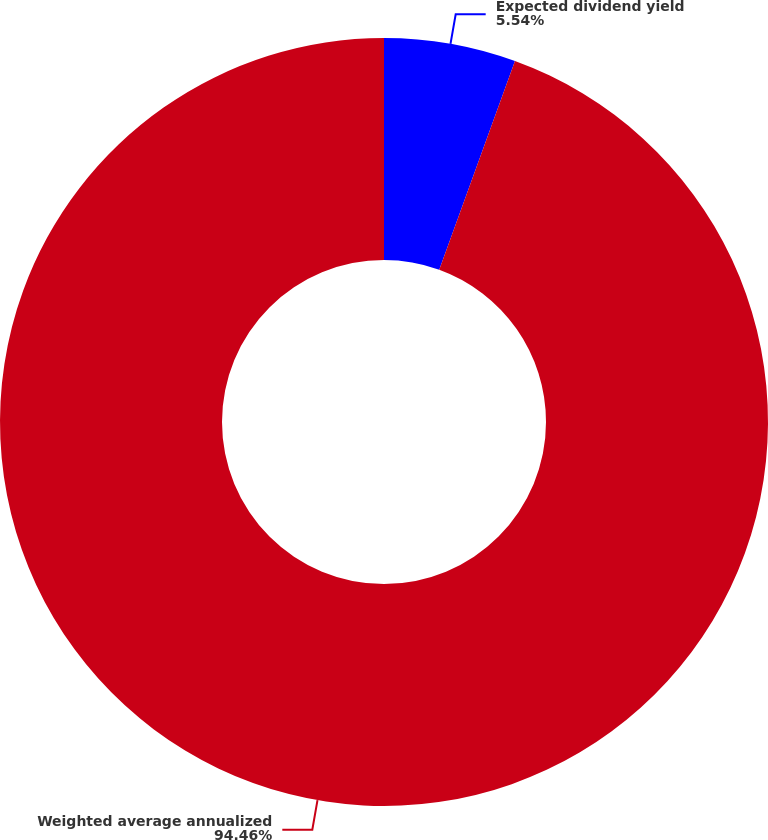<chart> <loc_0><loc_0><loc_500><loc_500><pie_chart><fcel>Expected dividend yield<fcel>Weighted average annualized<nl><fcel>5.54%<fcel>94.46%<nl></chart> 